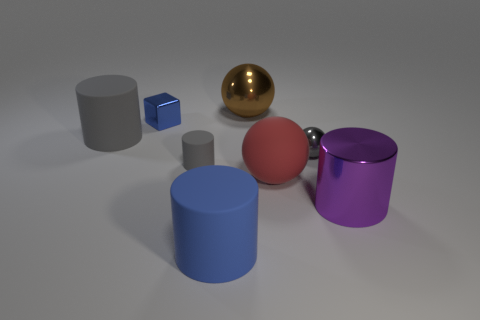Add 1 small blue objects. How many objects exist? 9 Subtract all shiny balls. How many balls are left? 1 Add 5 gray things. How many gray things exist? 8 Subtract all red spheres. How many spheres are left? 2 Subtract 1 purple cylinders. How many objects are left? 7 Subtract all balls. How many objects are left? 5 Subtract 1 cubes. How many cubes are left? 0 Subtract all green balls. Subtract all cyan cylinders. How many balls are left? 3 Subtract all cyan cubes. How many gray cylinders are left? 2 Subtract all blue objects. Subtract all large red rubber things. How many objects are left? 5 